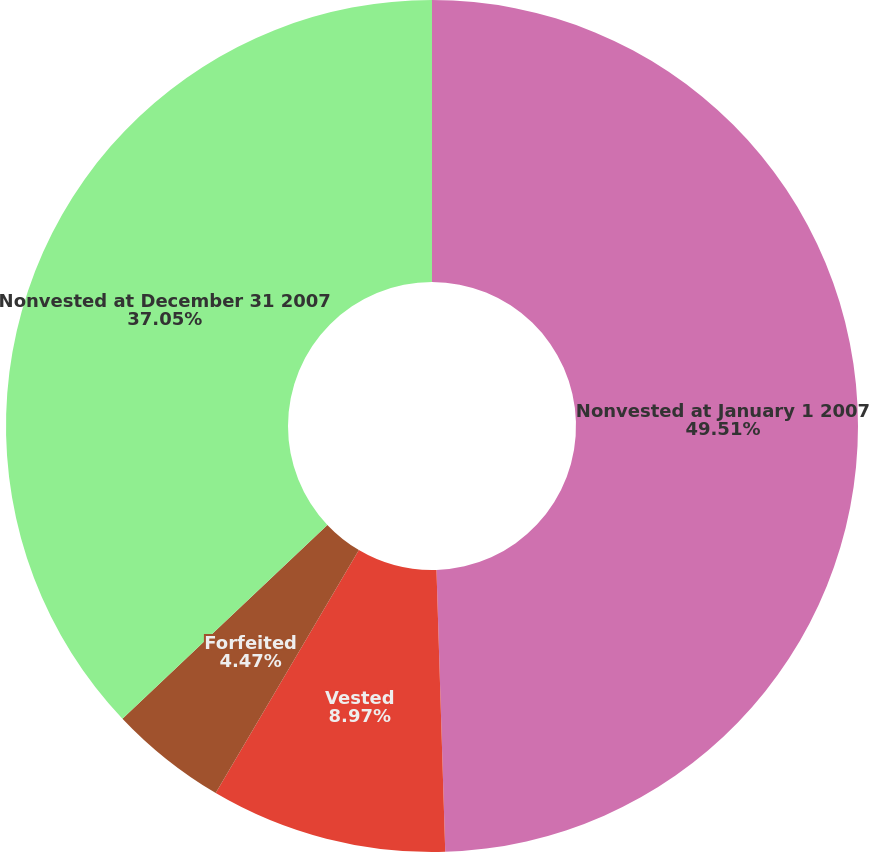Convert chart. <chart><loc_0><loc_0><loc_500><loc_500><pie_chart><fcel>Nonvested at January 1 2007<fcel>Vested<fcel>Forfeited<fcel>Nonvested at December 31 2007<nl><fcel>49.5%<fcel>8.97%<fcel>4.47%<fcel>37.05%<nl></chart> 